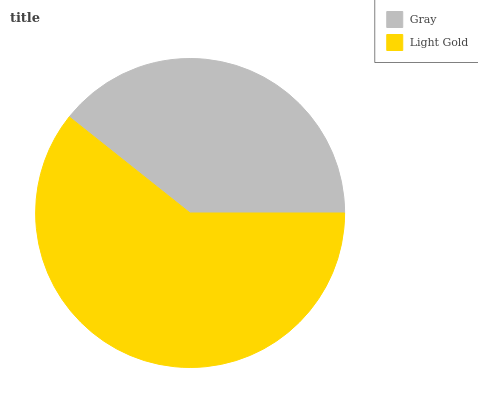Is Gray the minimum?
Answer yes or no. Yes. Is Light Gold the maximum?
Answer yes or no. Yes. Is Light Gold the minimum?
Answer yes or no. No. Is Light Gold greater than Gray?
Answer yes or no. Yes. Is Gray less than Light Gold?
Answer yes or no. Yes. Is Gray greater than Light Gold?
Answer yes or no. No. Is Light Gold less than Gray?
Answer yes or no. No. Is Light Gold the high median?
Answer yes or no. Yes. Is Gray the low median?
Answer yes or no. Yes. Is Gray the high median?
Answer yes or no. No. Is Light Gold the low median?
Answer yes or no. No. 